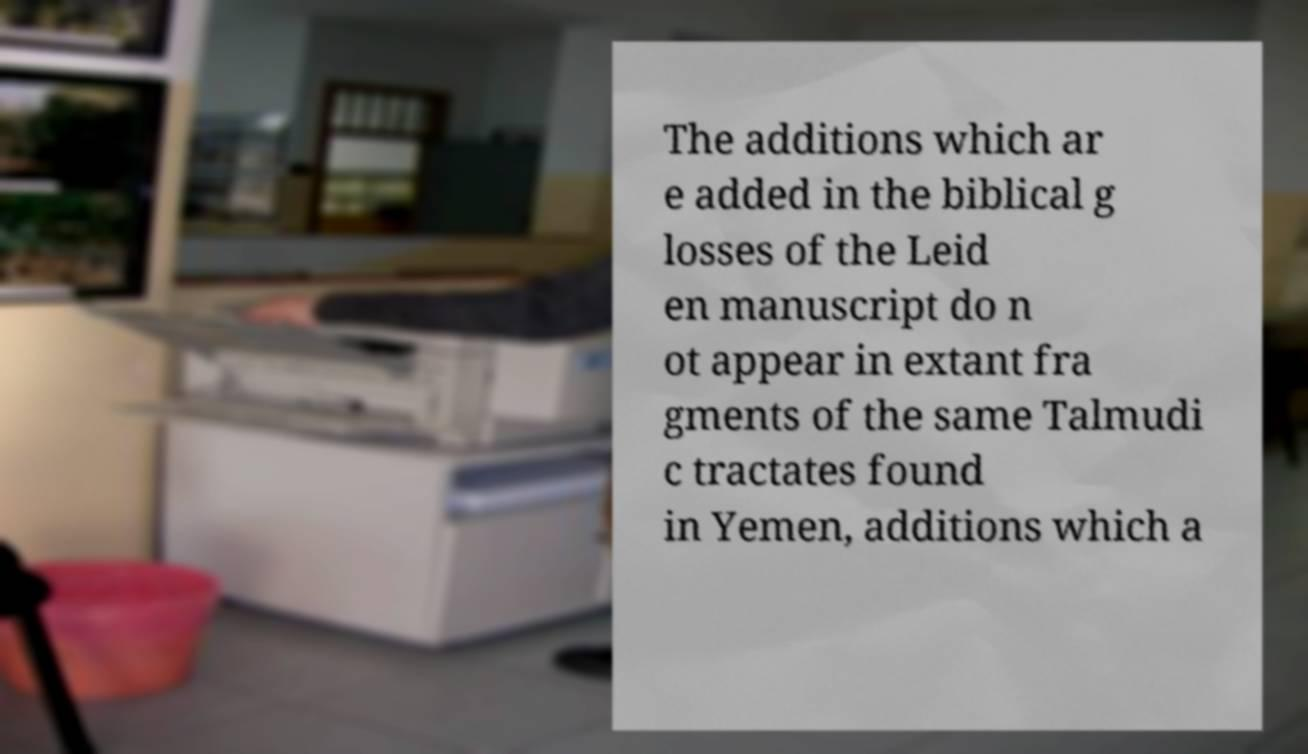I need the written content from this picture converted into text. Can you do that? The additions which ar e added in the biblical g losses of the Leid en manuscript do n ot appear in extant fra gments of the same Talmudi c tractates found in Yemen, additions which a 